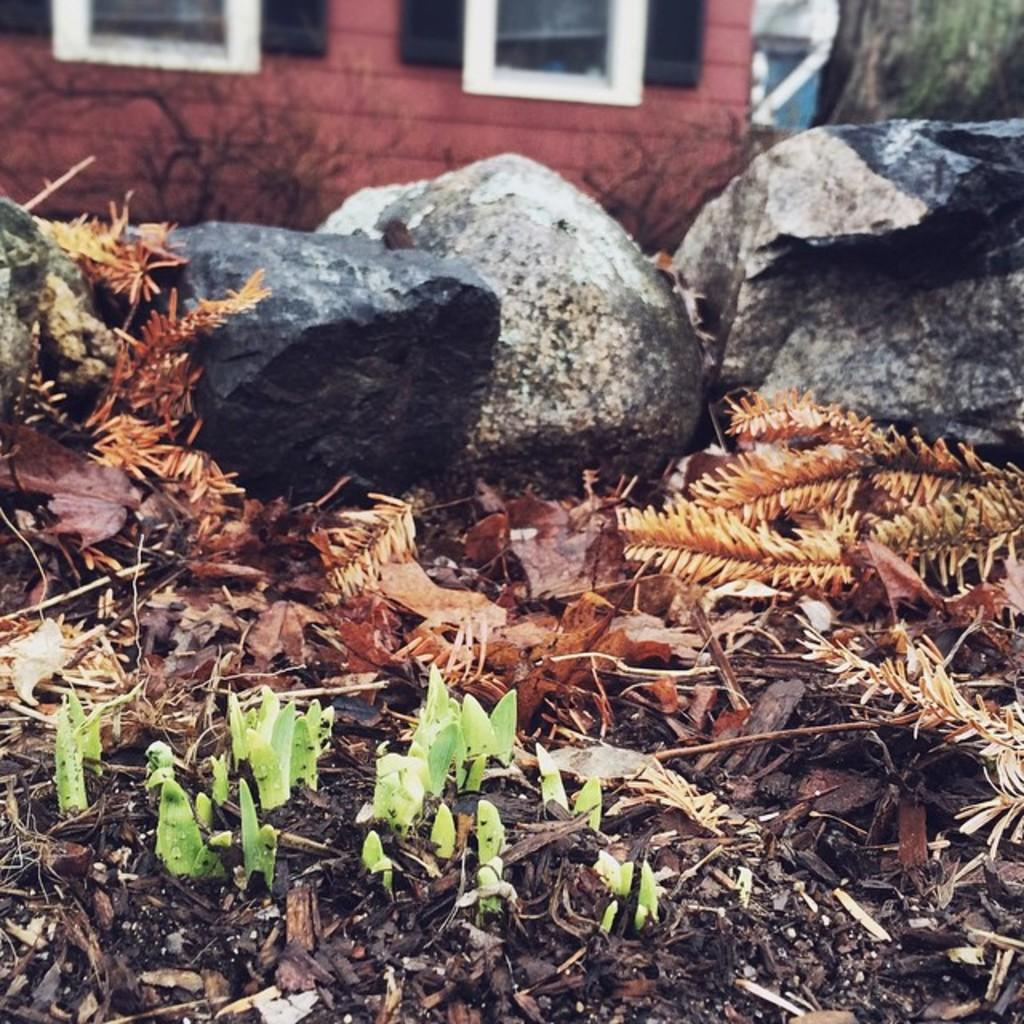What type of natural elements can be seen in the image? There are leaves in the image. What other objects are present in the image? There are stones in the image. What can be seen in the background of the image? There is a house in the background of the image. What is the color of the house in the image? The house is red in color. Are there any rabbits visible in the image? There are no rabbits present in the image. How many icicles are hanging from the roof of the house in the image? There is no mention of icicles in the image, so it cannot be determined if any are present. 